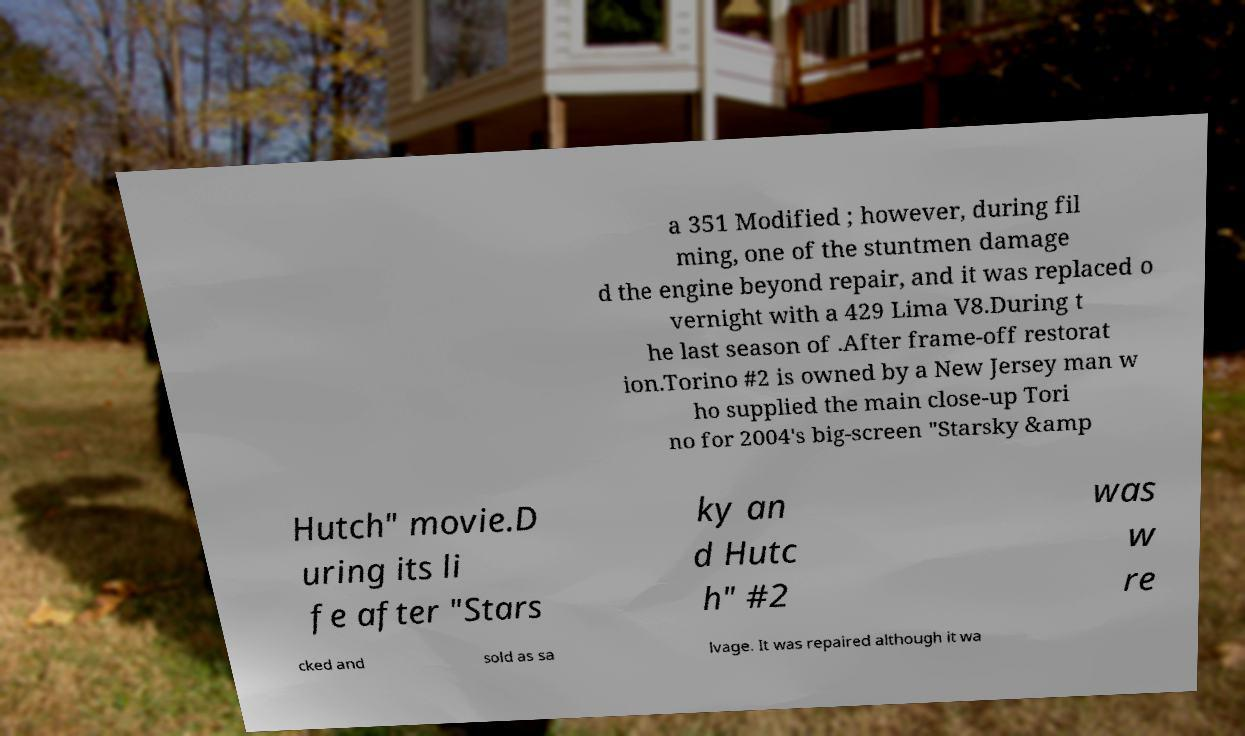Could you assist in decoding the text presented in this image and type it out clearly? a 351 Modified ; however, during fil ming, one of the stuntmen damage d the engine beyond repair, and it was replaced o vernight with a 429 Lima V8.During t he last season of .After frame-off restorat ion.Torino #2 is owned by a New Jersey man w ho supplied the main close-up Tori no for 2004's big-screen "Starsky &amp Hutch" movie.D uring its li fe after "Stars ky an d Hutc h" #2 was w re cked and sold as sa lvage. It was repaired although it wa 